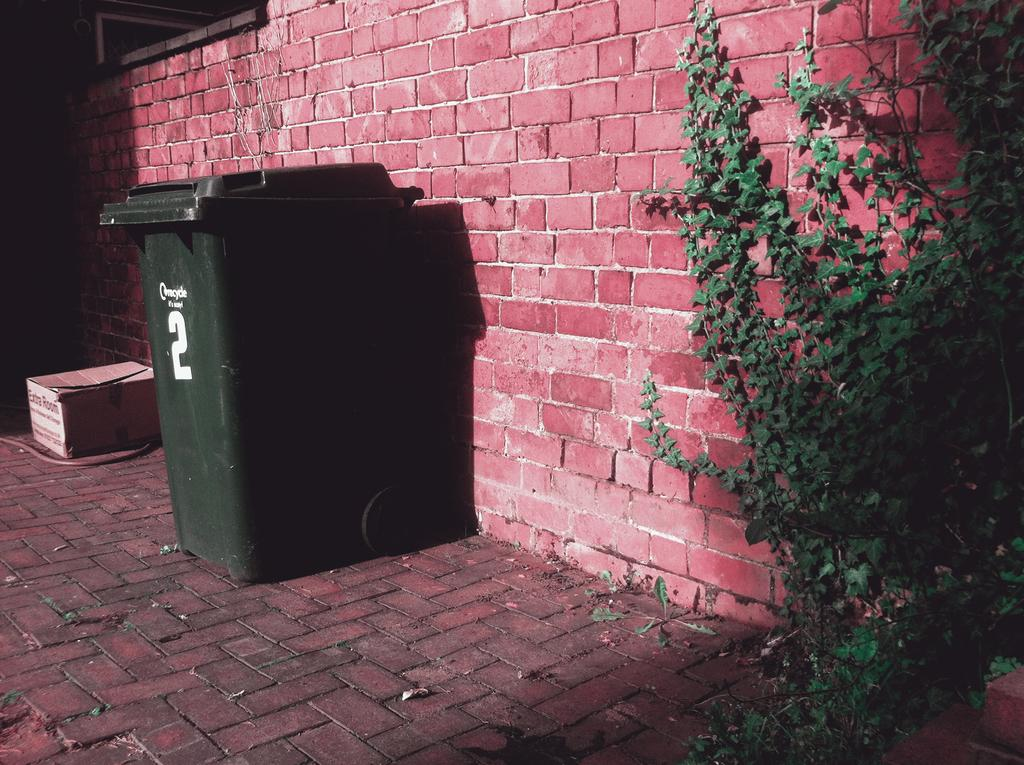<image>
Create a compact narrative representing the image presented. A trash bin marked 2 is sitting in front of a red brick wall. 